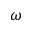Convert formula to latex. <formula><loc_0><loc_0><loc_500><loc_500>\omega</formula> 